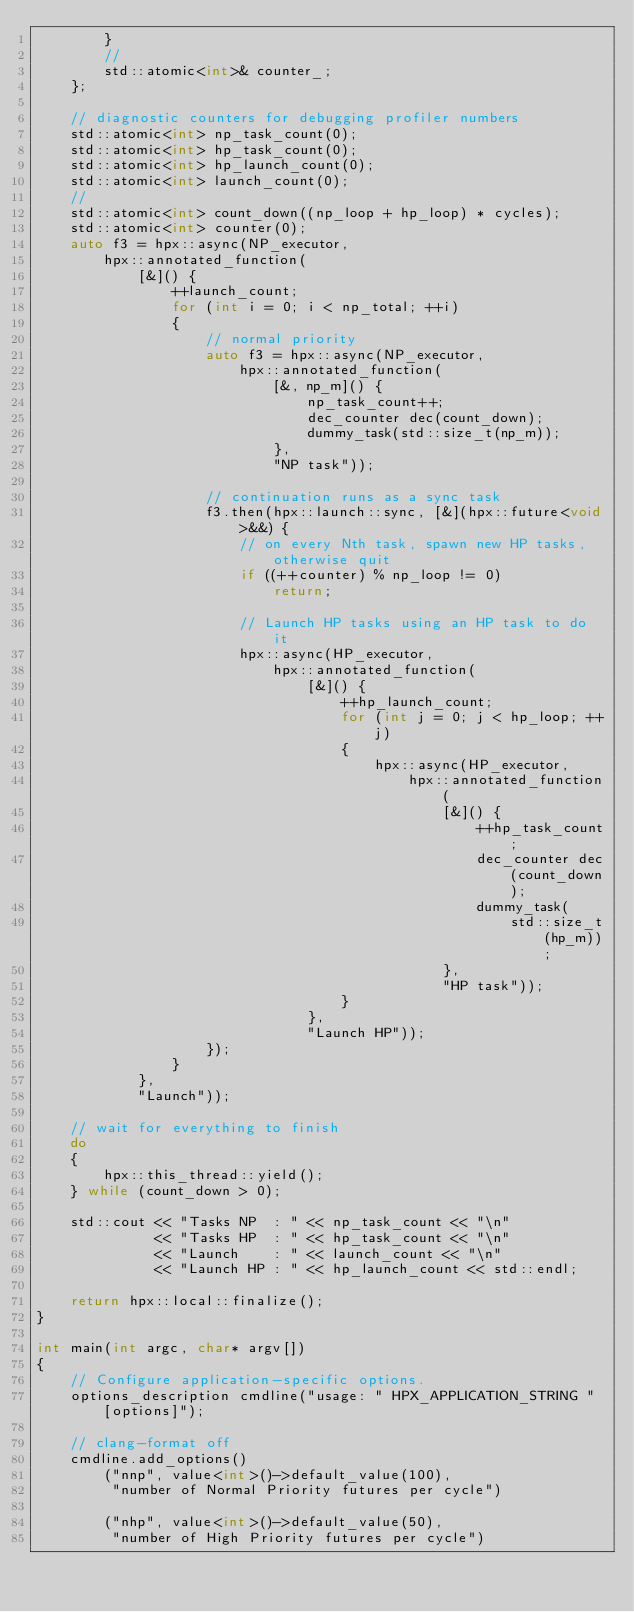<code> <loc_0><loc_0><loc_500><loc_500><_C++_>        }
        //
        std::atomic<int>& counter_;
    };

    // diagnostic counters for debugging profiler numbers
    std::atomic<int> np_task_count(0);
    std::atomic<int> hp_task_count(0);
    std::atomic<int> hp_launch_count(0);
    std::atomic<int> launch_count(0);
    //
    std::atomic<int> count_down((np_loop + hp_loop) * cycles);
    std::atomic<int> counter(0);
    auto f3 = hpx::async(NP_executor,
        hpx::annotated_function(
            [&]() {
                ++launch_count;
                for (int i = 0; i < np_total; ++i)
                {
                    // normal priority
                    auto f3 = hpx::async(NP_executor,
                        hpx::annotated_function(
                            [&, np_m]() {
                                np_task_count++;
                                dec_counter dec(count_down);
                                dummy_task(std::size_t(np_m));
                            },
                            "NP task"));

                    // continuation runs as a sync task
                    f3.then(hpx::launch::sync, [&](hpx::future<void>&&) {
                        // on every Nth task, spawn new HP tasks, otherwise quit
                        if ((++counter) % np_loop != 0)
                            return;

                        // Launch HP tasks using an HP task to do it
                        hpx::async(HP_executor,
                            hpx::annotated_function(
                                [&]() {
                                    ++hp_launch_count;
                                    for (int j = 0; j < hp_loop; ++j)
                                    {
                                        hpx::async(HP_executor,
                                            hpx::annotated_function(
                                                [&]() {
                                                    ++hp_task_count;
                                                    dec_counter dec(count_down);
                                                    dummy_task(
                                                        std::size_t(hp_m));
                                                },
                                                "HP task"));
                                    }
                                },
                                "Launch HP"));
                    });
                }
            },
            "Launch"));

    // wait for everything to finish
    do
    {
        hpx::this_thread::yield();
    } while (count_down > 0);

    std::cout << "Tasks NP  : " << np_task_count << "\n"
              << "Tasks HP  : " << hp_task_count << "\n"
              << "Launch    : " << launch_count << "\n"
              << "Launch HP : " << hp_launch_count << std::endl;

    return hpx::local::finalize();
}

int main(int argc, char* argv[])
{
    // Configure application-specific options.
    options_description cmdline("usage: " HPX_APPLICATION_STRING " [options]");

    // clang-format off
    cmdline.add_options()
        ("nnp", value<int>()->default_value(100),
         "number of Normal Priority futures per cycle")

        ("nhp", value<int>()->default_value(50),
         "number of High Priority futures per cycle")
</code> 